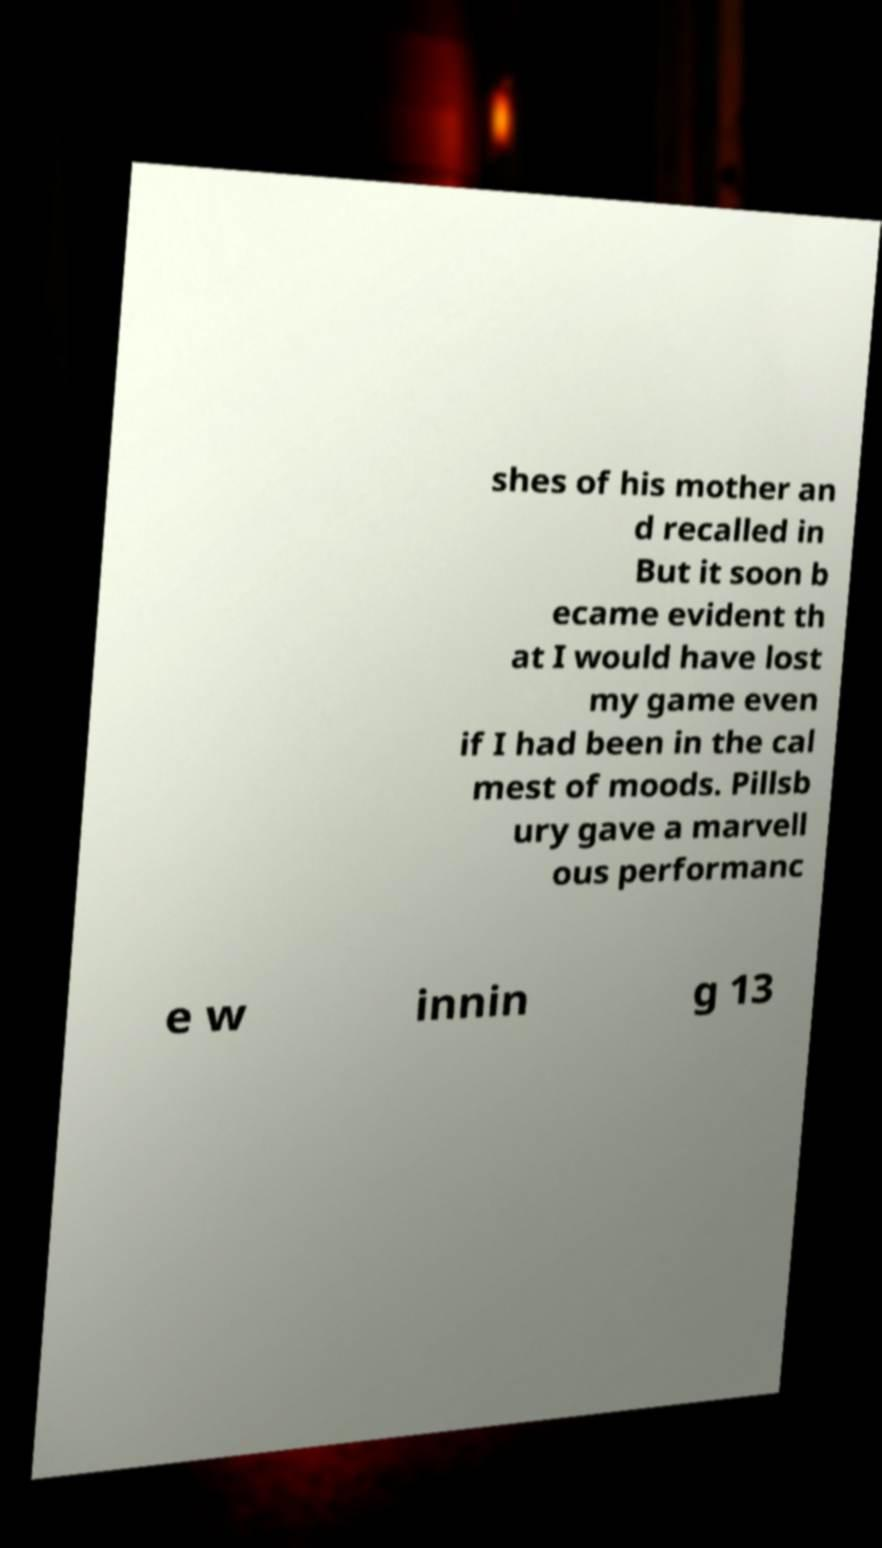Please identify and transcribe the text found in this image. shes of his mother an d recalled in But it soon b ecame evident th at I would have lost my game even if I had been in the cal mest of moods. Pillsb ury gave a marvell ous performanc e w innin g 13 